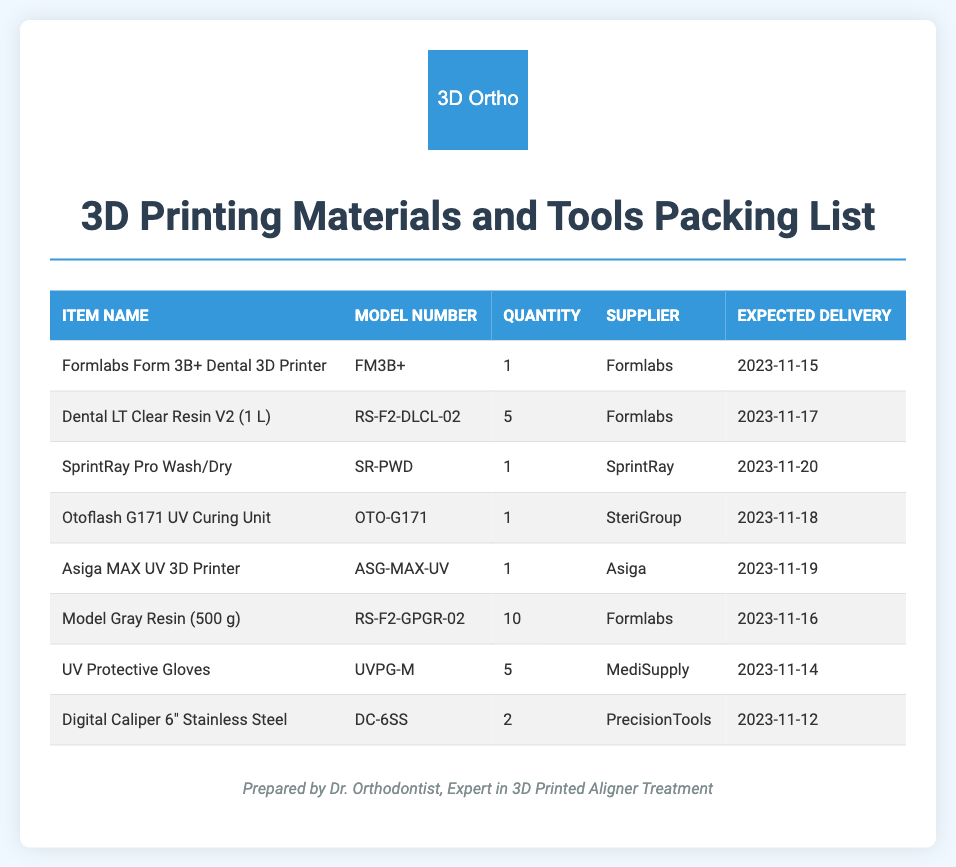what is the model number for the Formlabs Form 3B+ Dental 3D Printer? The model number for the Formlabs Form 3B+ Dental 3D Printer is specified in the document under the model number column.
Answer: FM3B+ how many Dental LT Clear Resin V2 (1 L) are ordered? The quantity of Dental LT Clear Resin V2 (1 L) can be found in the quantity column of the document for that item.
Answer: 5 which supplier provides the Otoflash G171 UV Curing Unit? The supplier for the Otoflash G171 UV Curing Unit is listed in the document under the supplier column.
Answer: SteriGroup what is the expected delivery date for the Digital Caliper 6" Stainless Steel? The expected delivery date can be found in the document in the expected delivery column for that item.
Answer: 2023-11-12 how many total different items are listed in the packing list? The total number of different items can be counted from the number of rows in the item section of the document.
Answer: 8 which item has the highest quantity ordered? The item with the highest quantity ordered can be determined by comparing the quantities in the document.
Answer: Model Gray Resin (500 g) who prepared the packing list? The name of the person who prepared the packing list is noted at the bottom of the document.
Answer: Dr. Orthodontist what type of document is this? This document is identified by its structure and content, specifically related to ordering supplies and materials.
Answer: Packing list 